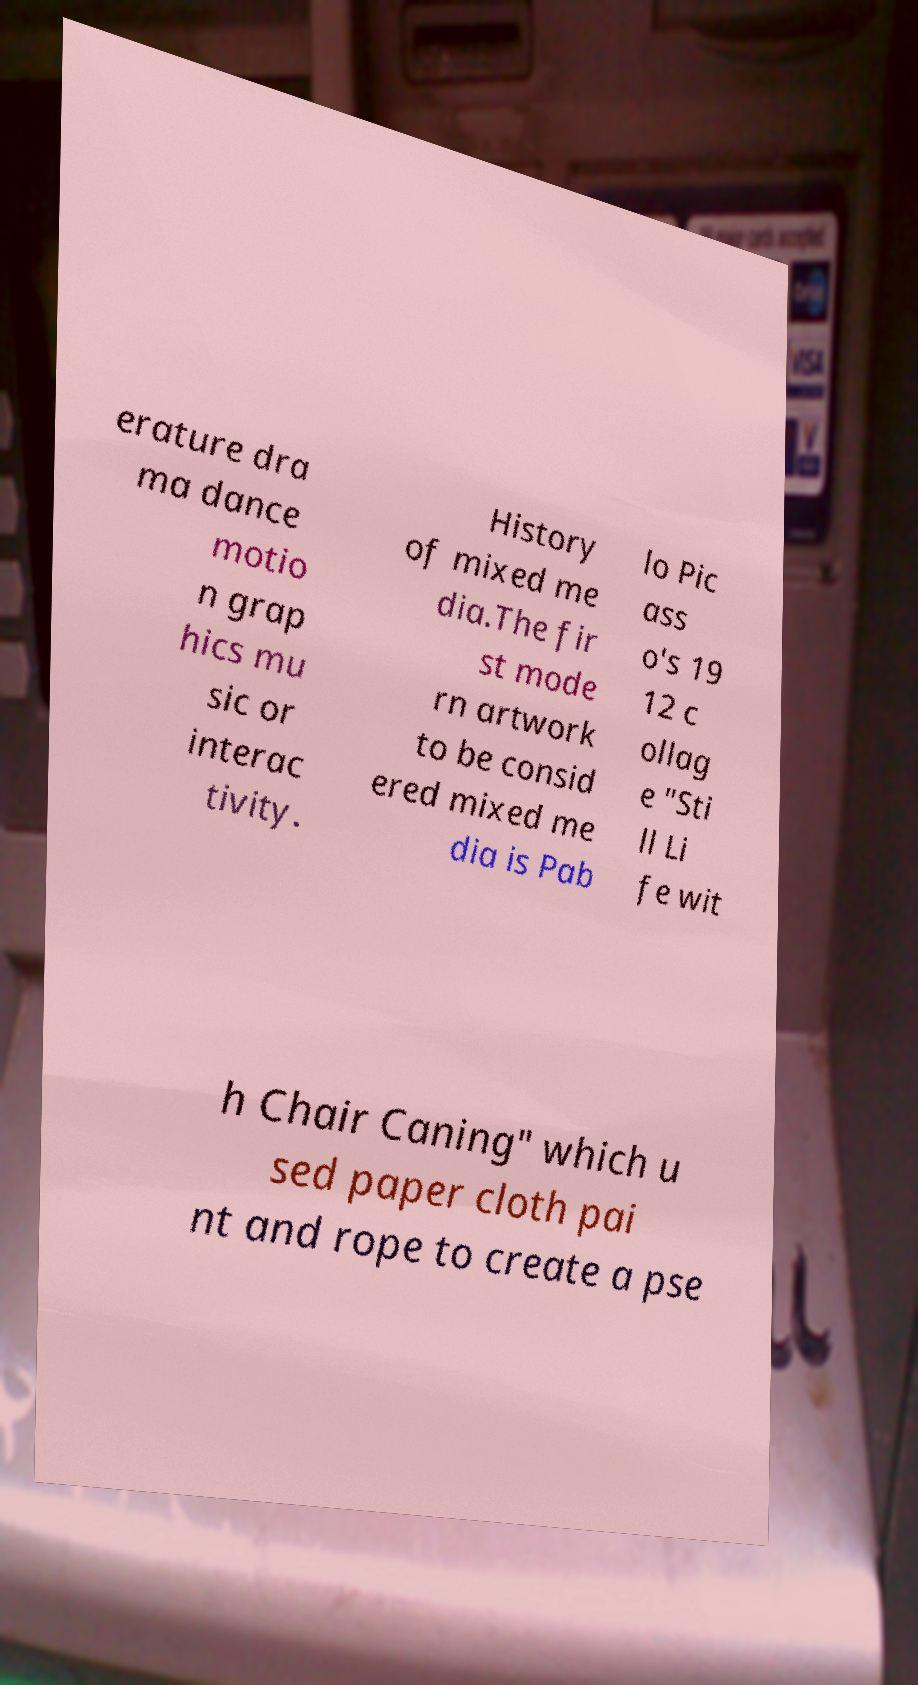For documentation purposes, I need the text within this image transcribed. Could you provide that? erature dra ma dance motio n grap hics mu sic or interac tivity. History of mixed me dia.The fir st mode rn artwork to be consid ered mixed me dia is Pab lo Pic ass o's 19 12 c ollag e "Sti ll Li fe wit h Chair Caning" which u sed paper cloth pai nt and rope to create a pse 